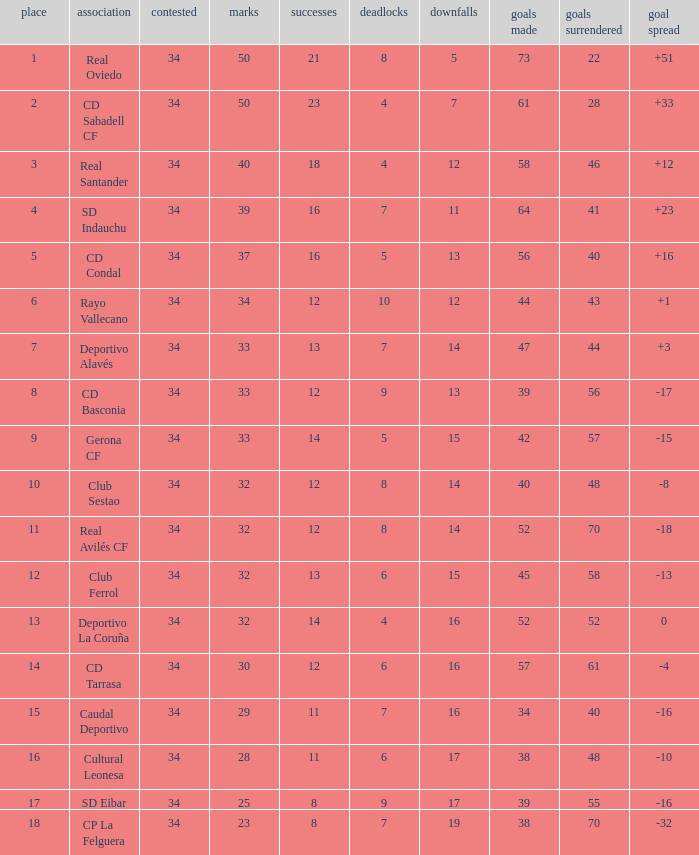How many Goals against have Played more than 34? 0.0. 